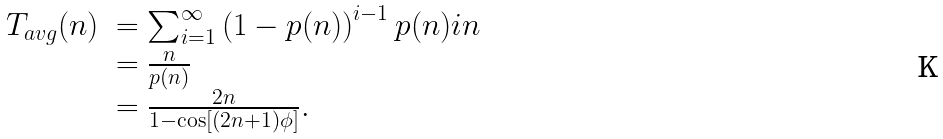Convert formula to latex. <formula><loc_0><loc_0><loc_500><loc_500>\begin{array} { r l } T _ { a v g } ( n ) & = \sum _ { i = 1 } ^ { \infty } \left ( 1 - p ( n ) \right ) ^ { i - 1 } p ( n ) i n \\ & = \frac { n } { p ( n ) } \\ & = \frac { 2 n } { 1 - \cos [ ( 2 n + 1 ) \phi ] } . \end{array}</formula> 